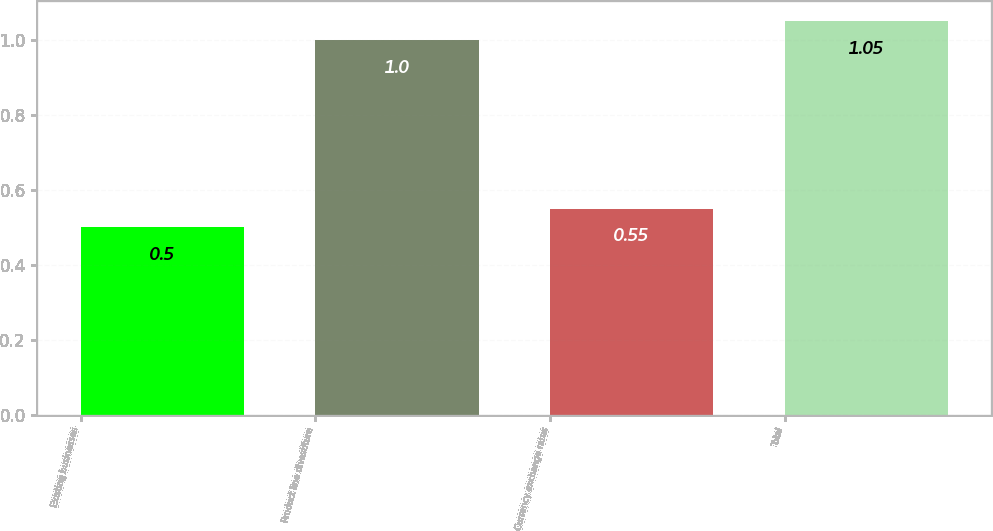Convert chart to OTSL. <chart><loc_0><loc_0><loc_500><loc_500><bar_chart><fcel>Existing businesses<fcel>Product line divestiture<fcel>Currency exchange rates<fcel>Total<nl><fcel>0.5<fcel>1<fcel>0.55<fcel>1.05<nl></chart> 